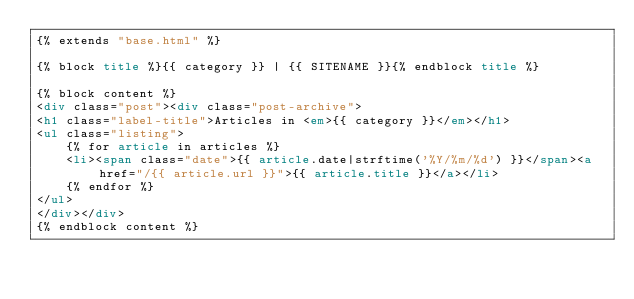<code> <loc_0><loc_0><loc_500><loc_500><_HTML_>{% extends "base.html" %}

{% block title %}{{ category }} | {{ SITENAME }}{% endblock title %}

{% block content %}
<div class="post"><div class="post-archive">
<h1 class="label-title">Articles in <em>{{ category }}</em></h1>
<ul class="listing">
    {% for article in articles %}
    <li><span class="date">{{ article.date|strftime('%Y/%m/%d') }}</span><a href="/{{ article.url }}">{{ article.title }}</a></li>
    {% endfor %}
</ul>
</div></div>
{% endblock content %}</code> 